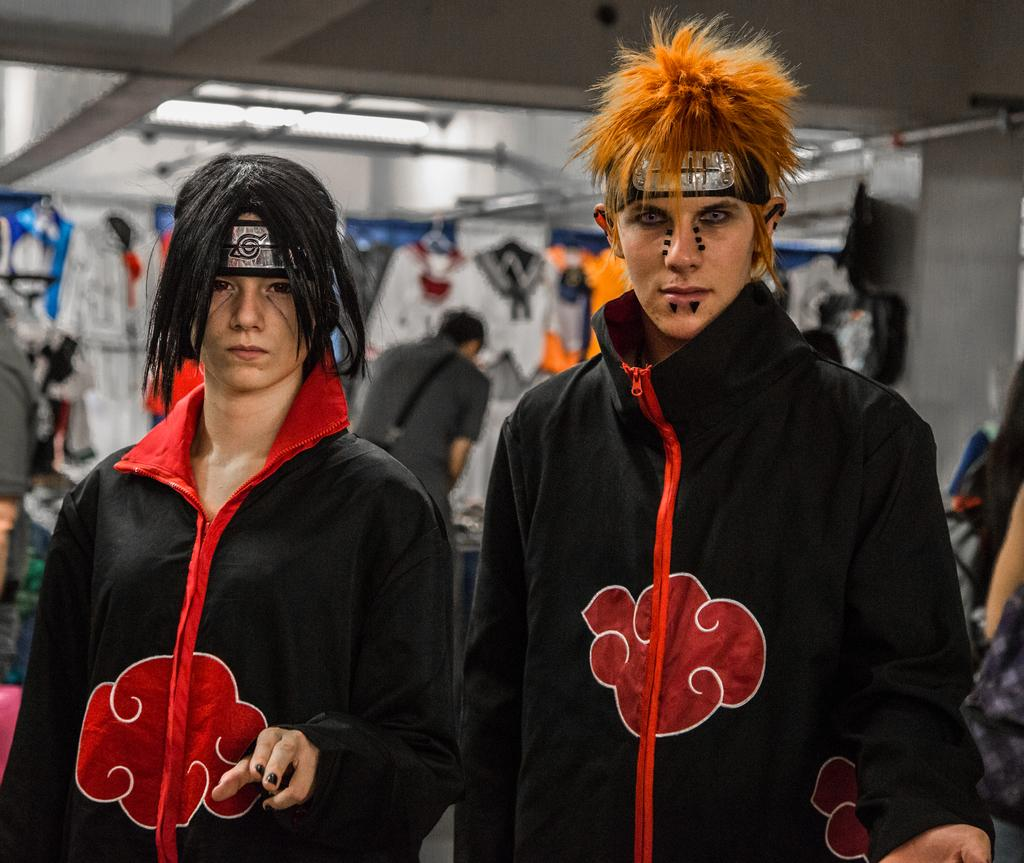How many people are present in the image? There are 2 people in the image. What are the people wearing? Both people are wearing black dresses. Can you describe anything else visible in the image? There are other people visible in the image, as well as clothes. What type of ice can be seen melting on the clothes in the image? There is no ice visible in the image, and therefore no ice can be seen melting on the clothes. 